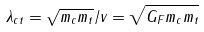Convert formula to latex. <formula><loc_0><loc_0><loc_500><loc_500>\lambda _ { c t } = \sqrt { m _ { c } m _ { t } } / v = \sqrt { G _ { F } m _ { c } m _ { t } }</formula> 